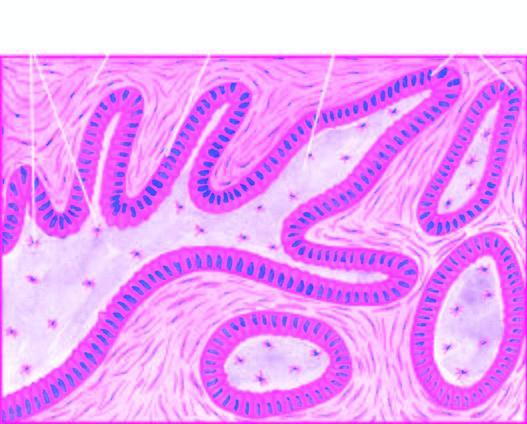what do plexiform areas show?
Answer the question using a single word or phrase. Irregular masses and network of strands of epithelial cells 